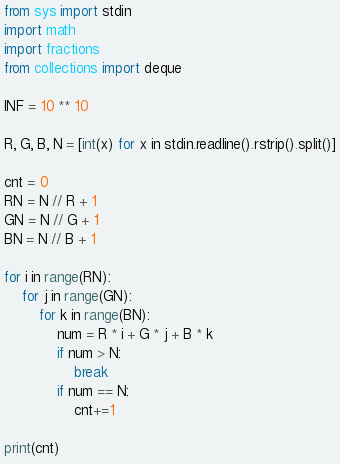<code> <loc_0><loc_0><loc_500><loc_500><_Python_>from sys import stdin
import math
import fractions
from collections import deque

INF = 10 ** 10

R, G, B, N = [int(x) for x in stdin.readline().rstrip().split()]

cnt = 0
RN = N // R + 1
GN = N // G + 1
BN = N // B + 1

for i in range(RN):
    for j in range(GN):
        for k in range(BN):
            num = R * i + G * j + B * k
            if num > N:
                break
            if num == N:
                cnt+=1

print(cnt)</code> 